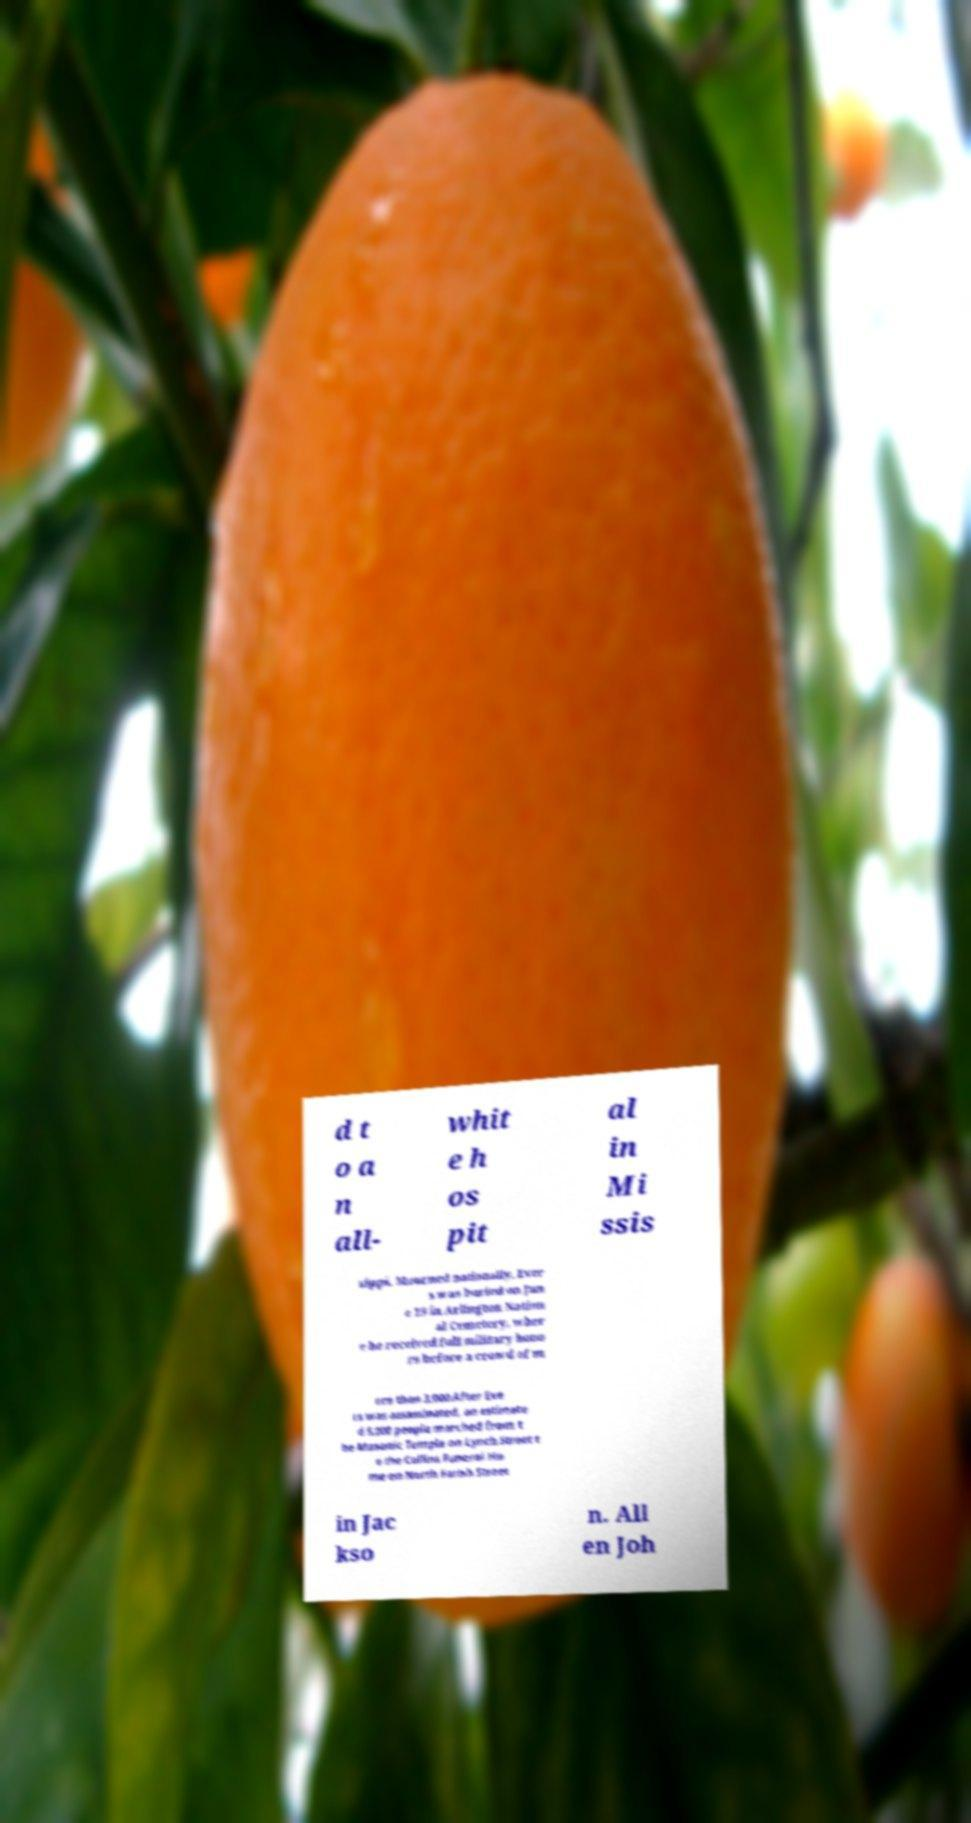Could you extract and type out the text from this image? d t o a n all- whit e h os pit al in Mi ssis sippi. Mourned nationally, Ever s was buried on Jun e 19 in Arlington Nation al Cemetery, wher e he received full military hono rs before a crowd of m ore than 3,000.After Eve rs was assassinated, an estimate d 5,000 people marched from t he Masonic Temple on Lynch Street t o the Collins Funeral Ho me on North Farish Street in Jac kso n. All en Joh 